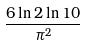<formula> <loc_0><loc_0><loc_500><loc_500>\frac { 6 \ln 2 \ln 1 0 } { \pi ^ { 2 } }</formula> 